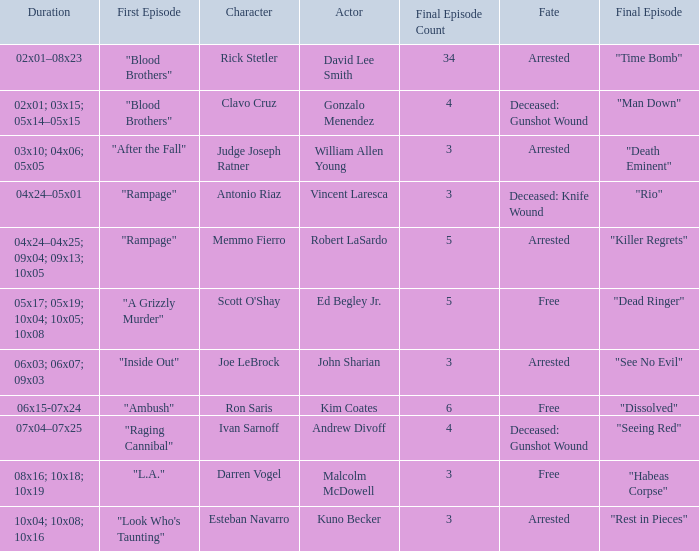What's the total number of final epbeingode count with first epbeingode being "l.a." 1.0. 